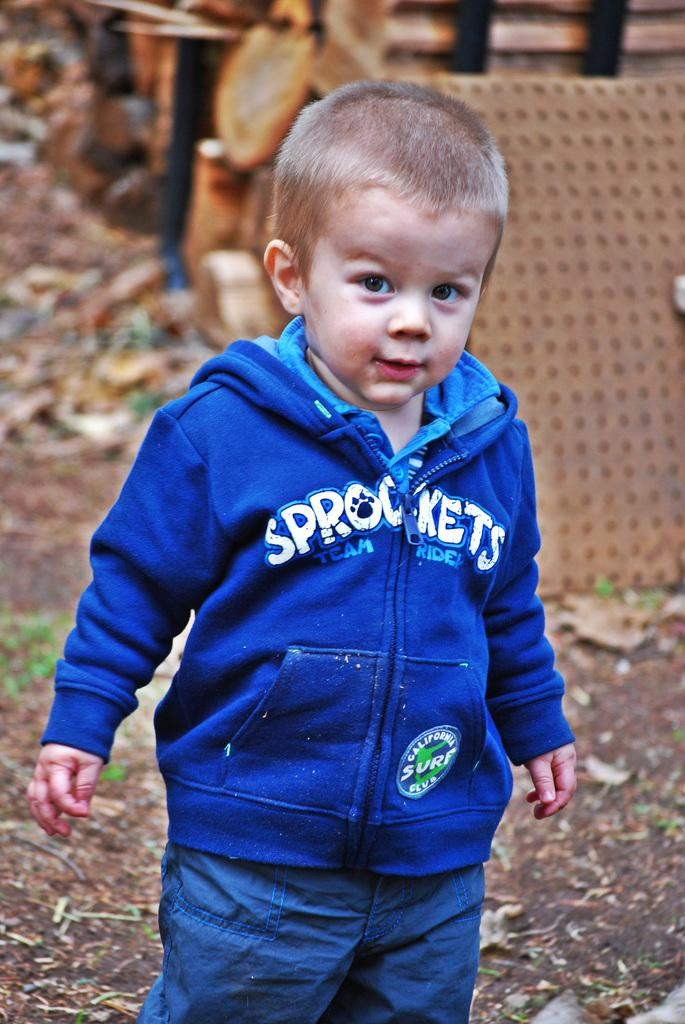<image>
Write a terse but informative summary of the picture. A child has on a blue jacket with the word sprockets on his jacket. 